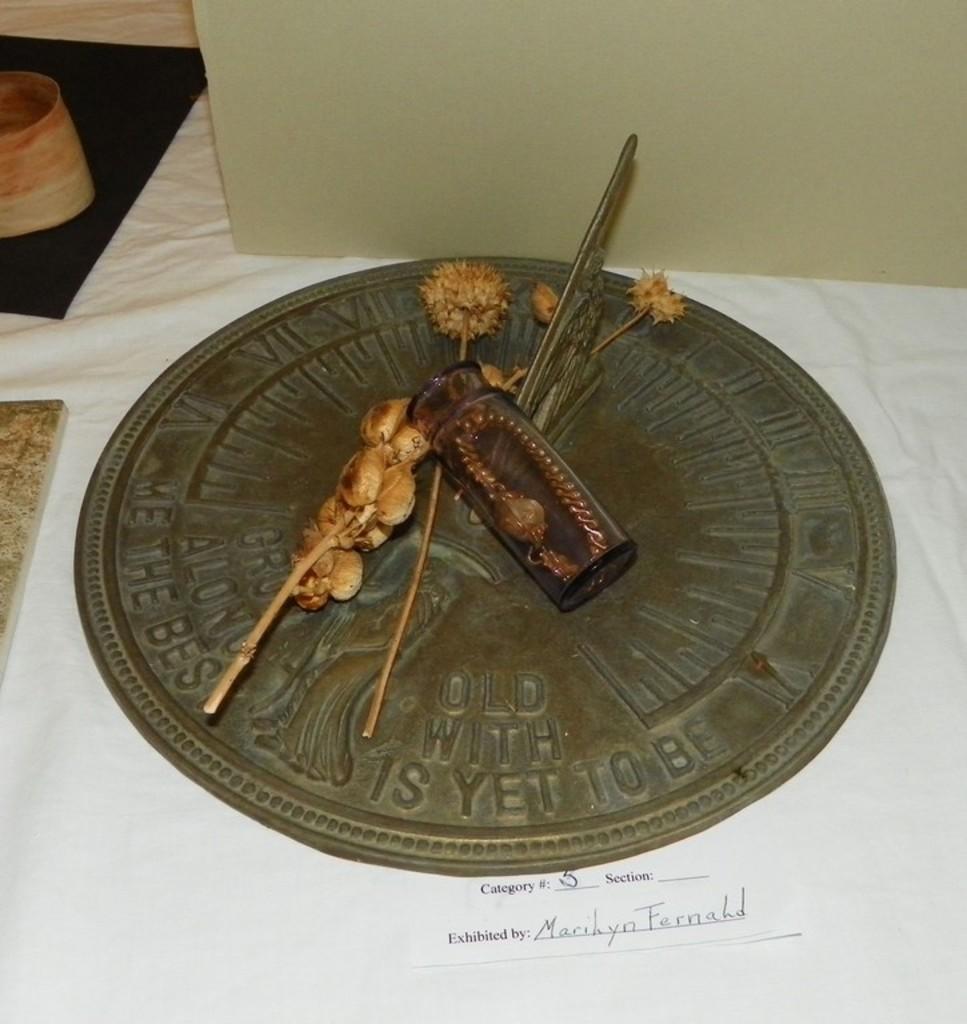How would you summarize this image in a sentence or two? In this image there are few artifacts. Beside the artifacts there are some objects on the table. At the bottom of the image there is some text on the paper. 